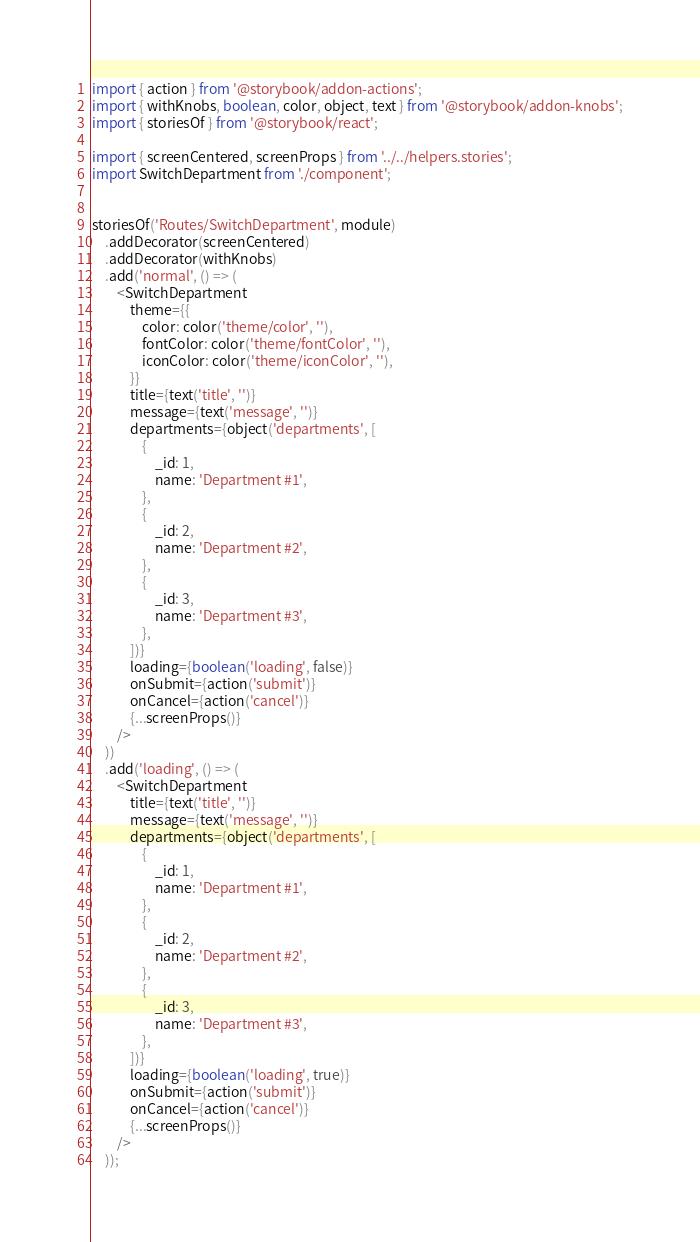<code> <loc_0><loc_0><loc_500><loc_500><_JavaScript_>import { action } from '@storybook/addon-actions';
import { withKnobs, boolean, color, object, text } from '@storybook/addon-knobs';
import { storiesOf } from '@storybook/react';

import { screenCentered, screenProps } from '../../helpers.stories';
import SwitchDepartment from './component';


storiesOf('Routes/SwitchDepartment', module)
	.addDecorator(screenCentered)
	.addDecorator(withKnobs)
	.add('normal', () => (
		<SwitchDepartment
			theme={{
				color: color('theme/color', ''),
				fontColor: color('theme/fontColor', ''),
				iconColor: color('theme/iconColor', ''),
			}}
			title={text('title', '')}
			message={text('message', '')}
			departments={object('departments', [
				{
					_id: 1,
					name: 'Department #1',
				},
				{
					_id: 2,
					name: 'Department #2',
				},
				{
					_id: 3,
					name: 'Department #3',
				},
			])}
			loading={boolean('loading', false)}
			onSubmit={action('submit')}
			onCancel={action('cancel')}
			{...screenProps()}
		/>
	))
	.add('loading', () => (
		<SwitchDepartment
			title={text('title', '')}
			message={text('message', '')}
			departments={object('departments', [
				{
					_id: 1,
					name: 'Department #1',
				},
				{
					_id: 2,
					name: 'Department #2',
				},
				{
					_id: 3,
					name: 'Department #3',
				},
			])}
			loading={boolean('loading', true)}
			onSubmit={action('submit')}
			onCancel={action('cancel')}
			{...screenProps()}
		/>
	));
</code> 